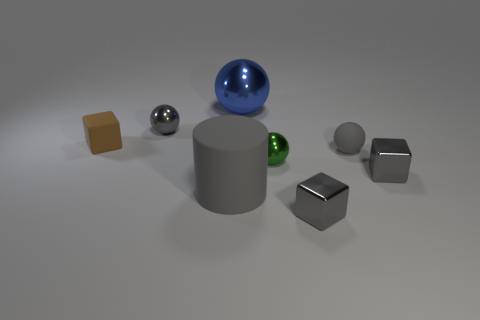How do the different surfaces of the objects affect the perception of depth in the image? The variation in textures and reflectivity greatly influences the perception of depth. The shiny surfaces of the metallic and glossy spheres create bright highlights and clear reflections, which indicate their curvature and distance from the light source and the camera. The more diffuse surfaces, such as the matte cubes, don't reflect much light so they offer a softer appearance, which can make their relative distance harder to judge. Additionally, the shadows each object casts contribute to the sense of three-dimensional space and the positioning of each form within that space. 